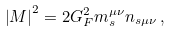Convert formula to latex. <formula><loc_0><loc_0><loc_500><loc_500>\left | M \right | ^ { 2 } = 2 G _ { F } ^ { 2 } m ^ { \mu \nu } _ { s } n _ { s \mu \nu } \, ,</formula> 